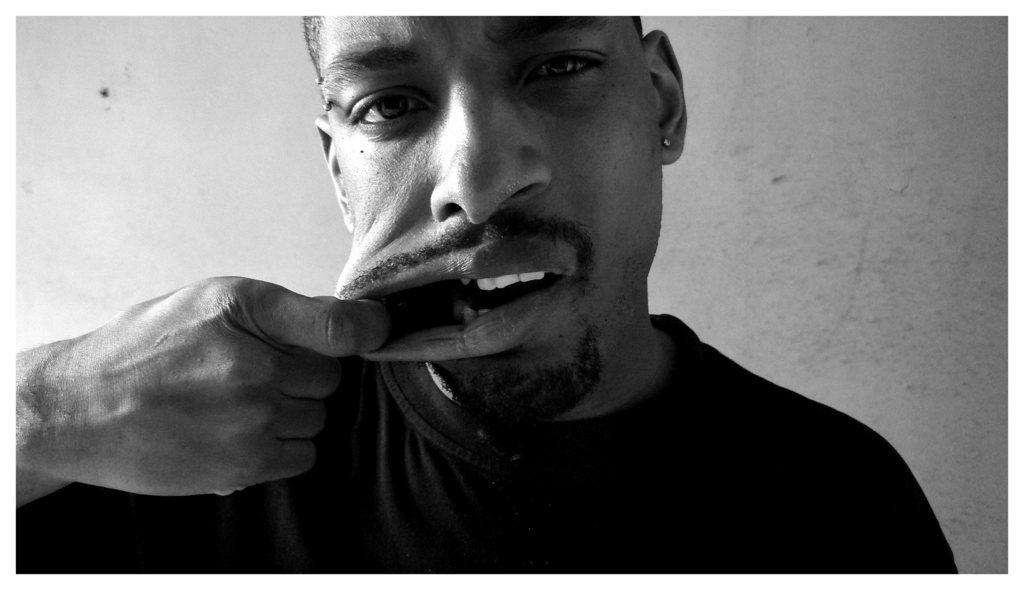What is the color scheme of the image? The image is black and white. Who is present in the image? There is a man in the image. What is the man doing in the image? The man is opening his mouth with his hand. What can be seen in the background of the image? There is a wall in the background of the image. What type of knee injury is the man experiencing in the image? There is no indication of a knee injury in the image; the man is opening his mouth with his hand. What flight number is the man trying to catch in the image? There is no reference to a flight or any travel-related context in the image. 